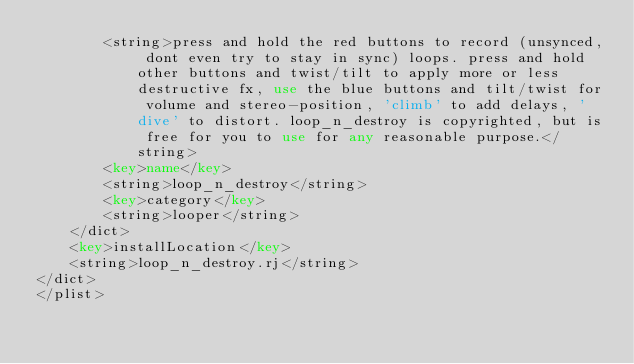Convert code to text. <code><loc_0><loc_0><loc_500><loc_500><_XML_>        <string>press and hold the red buttons to record (unsynced, dont even try to stay in sync) loops. press and hold other buttons and twist/tilt to apply more or less destructive fx, use the blue buttons and tilt/twist for volume and stereo-position, 'climb' to add delays, 'dive' to distort. loop_n_destroy is copyrighted, but is free for you to use for any reasonable purpose.</string>
		<key>name</key>
		<string>loop_n_destroy</string>
		<key>category</key>
		<string>looper</string>
	</dict>
    <key>installLocation</key>
	<string>loop_n_destroy.rj</string>
</dict>
</plist>
</code> 